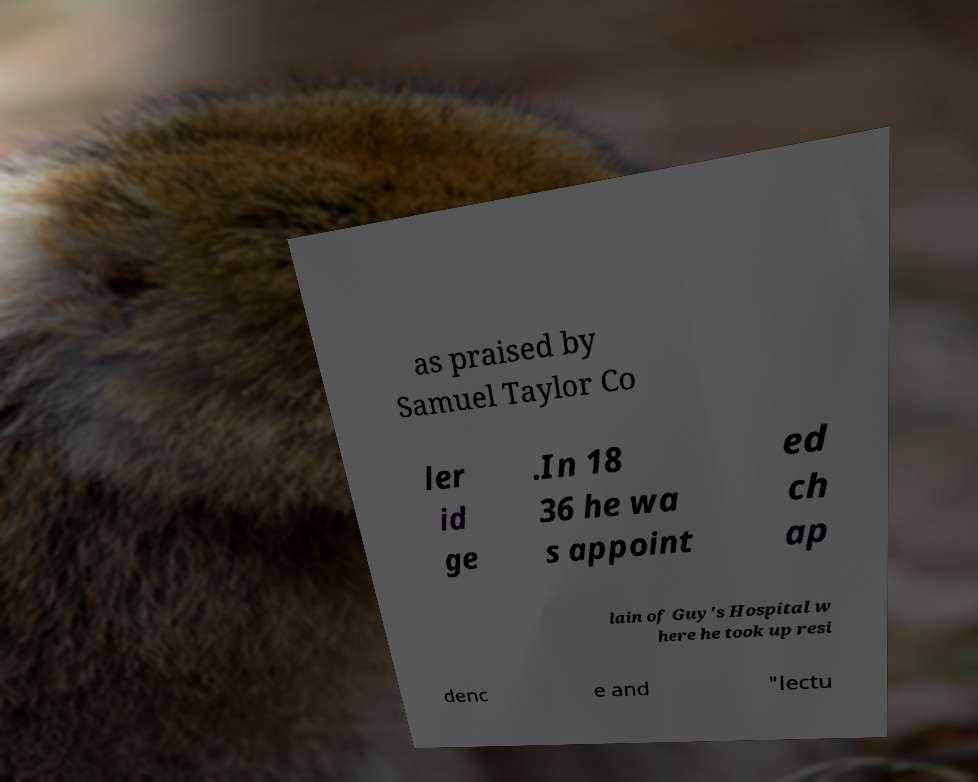I need the written content from this picture converted into text. Can you do that? as praised by Samuel Taylor Co ler id ge .In 18 36 he wa s appoint ed ch ap lain of Guy's Hospital w here he took up resi denc e and "lectu 